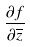<formula> <loc_0><loc_0><loc_500><loc_500>\frac { \partial f } { \partial \overline { z } }</formula> 